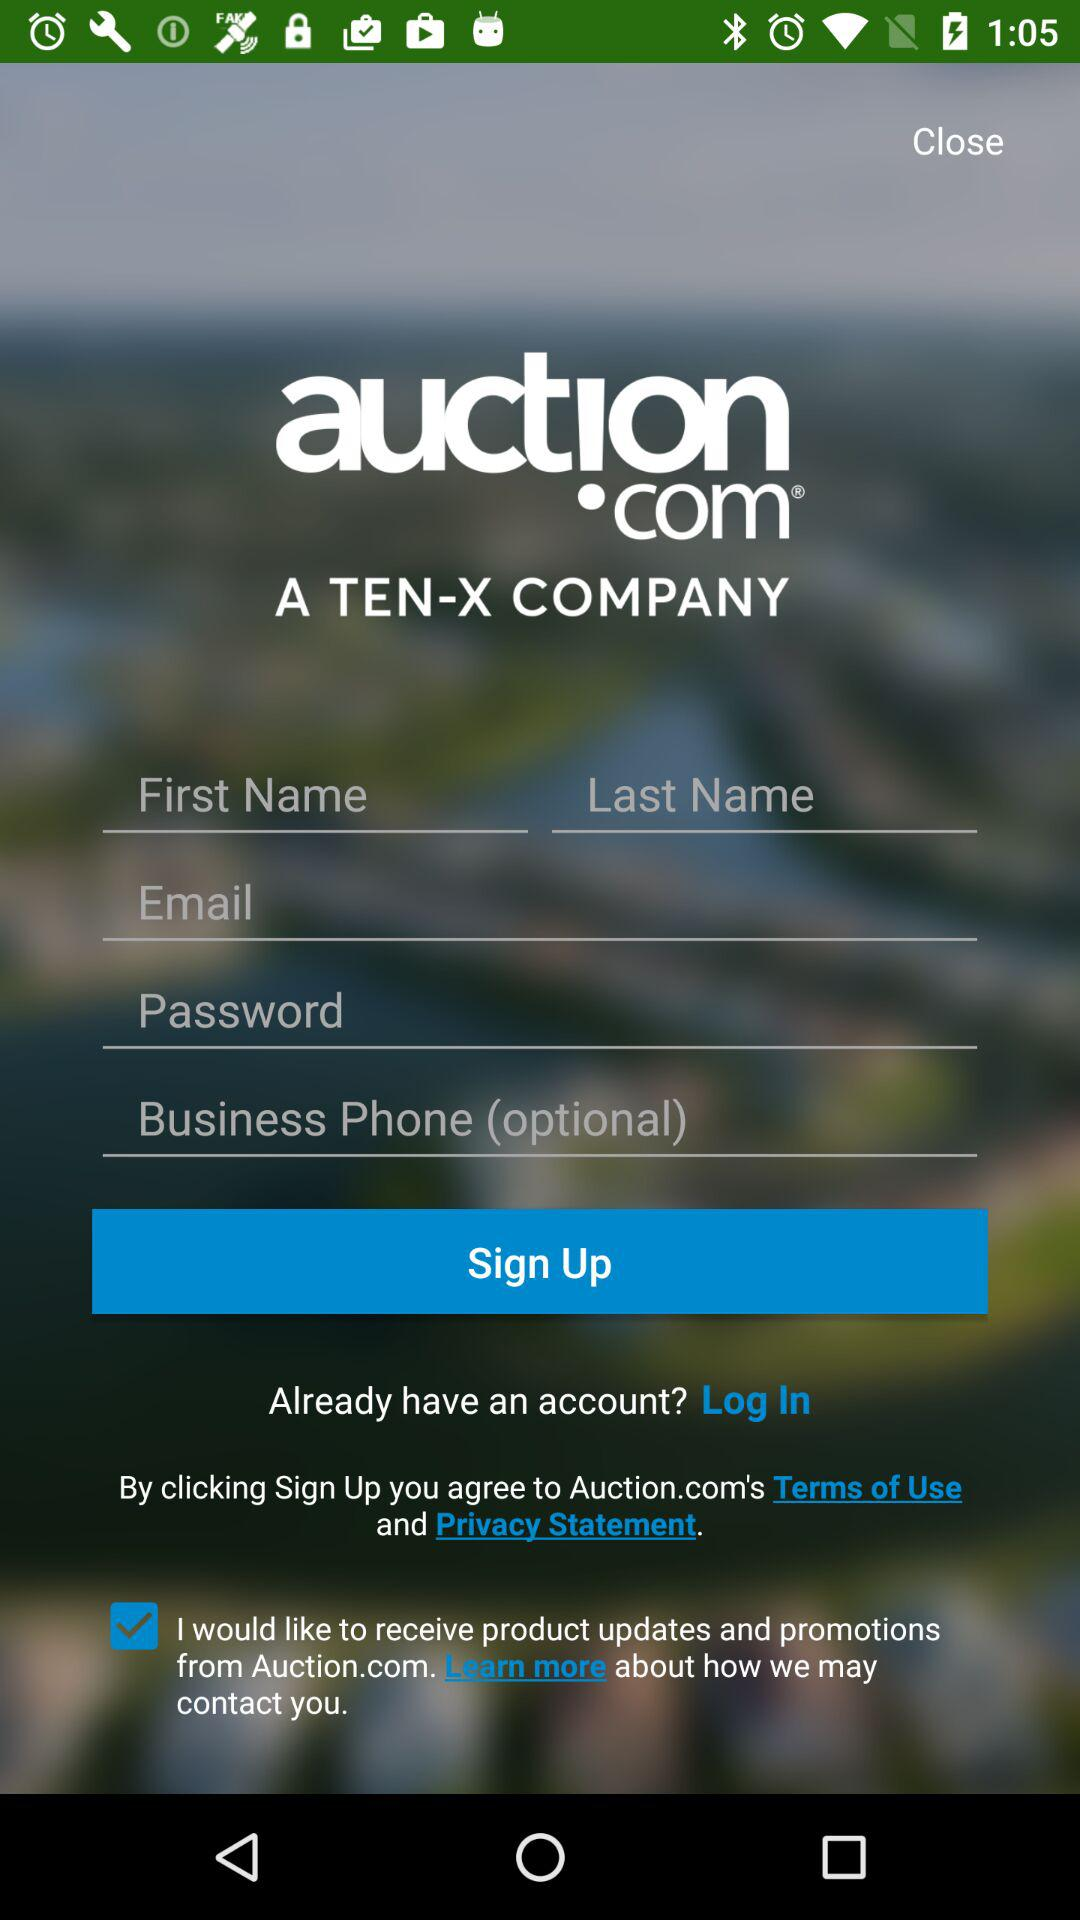What is the name of the company? The names of the companies are "auction.com" and "TEN-X". 